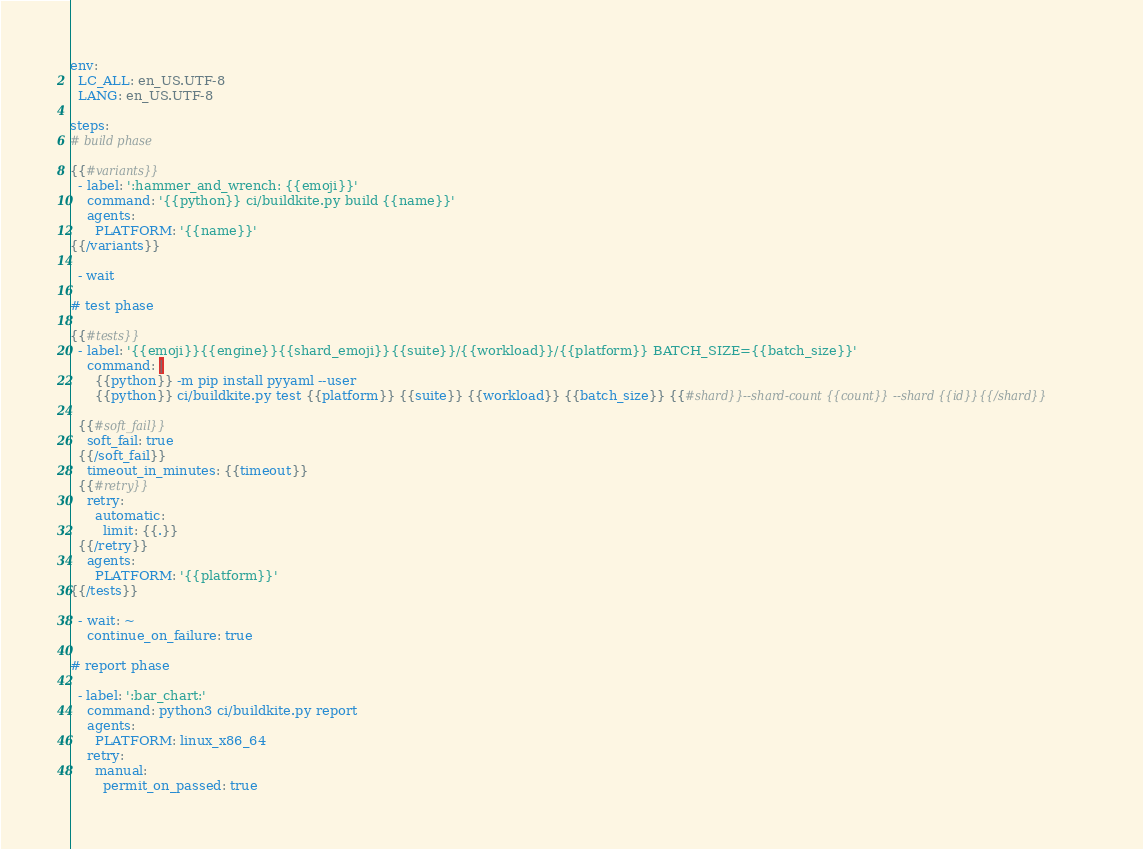<code> <loc_0><loc_0><loc_500><loc_500><_YAML_>env:
  LC_ALL: en_US.UTF-8
  LANG: en_US.UTF-8

steps:
# build phase

{{#variants}}
  - label: ':hammer_and_wrench: {{emoji}}'
    command: '{{python}} ci/buildkite.py build {{name}}'
    agents:
      PLATFORM: '{{name}}'
{{/variants}}

  - wait

# test phase

{{#tests}}
  - label: '{{emoji}}{{engine}}{{shard_emoji}}{{suite}}/{{workload}}/{{platform}} BATCH_SIZE={{batch_size}}'
    command: |
      {{python}} -m pip install pyyaml --user
      {{python}} ci/buildkite.py test {{platform}} {{suite}} {{workload}} {{batch_size}} {{#shard}}--shard-count {{count}} --shard {{id}}{{/shard}}

  {{#soft_fail}}
    soft_fail: true
  {{/soft_fail}}
    timeout_in_minutes: {{timeout}}
  {{#retry}}
    retry:
      automatic:
        limit: {{.}}
  {{/retry}}
    agents:
      PLATFORM: '{{platform}}'
{{/tests}}

  - wait: ~
    continue_on_failure: true

# report phase

  - label: ':bar_chart:'
    command: python3 ci/buildkite.py report
    agents:
      PLATFORM: linux_x86_64
    retry:
      manual:
        permit_on_passed: true
</code> 